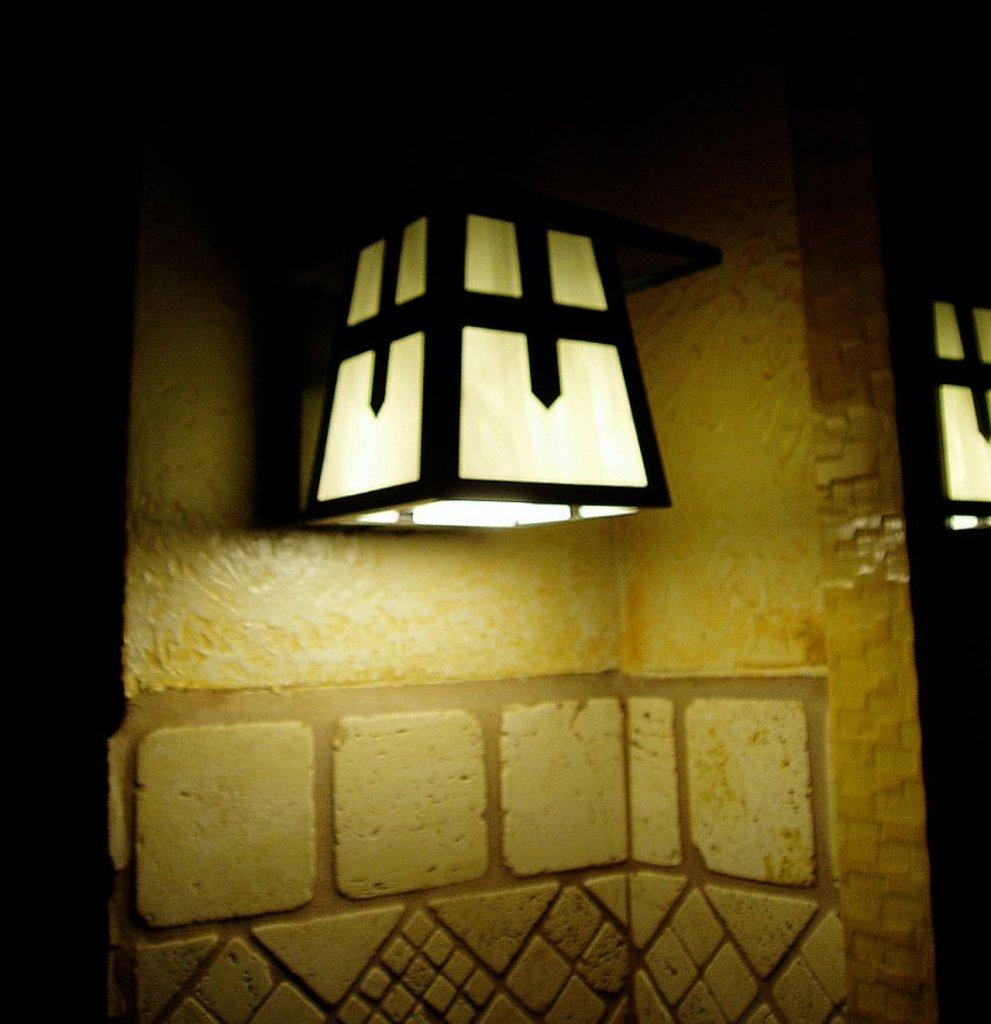What can be seen in the image that provides illumination? There is a light in the image. What type of structure is present in the background of the image? There is a wall in the image. What color of ink is used to write on the wall in the image? There is no writing or ink present on the wall in the image. What type of precious metal can be seen in the image? There is no precious metal, such as silver, present in the image. 